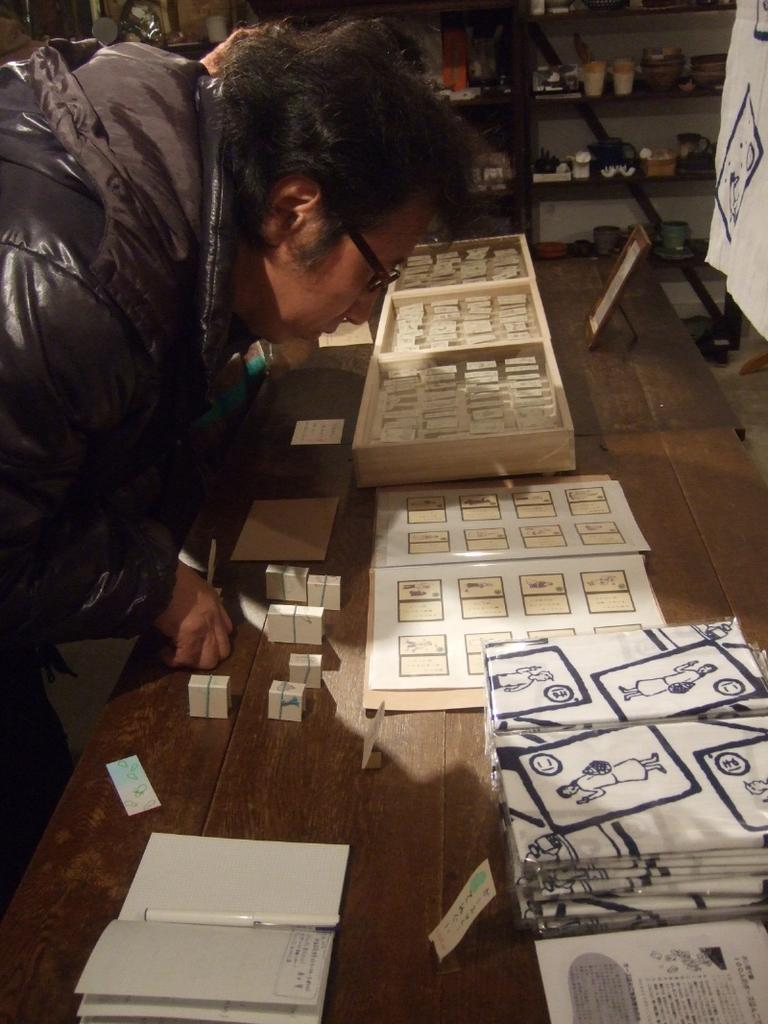Who is present in the image? There is a man in the image. What is in front of the man? There are tables in front of the man. What can be found on the tables? There are objects on the tables. What can be seen in the background of the image? There are racks in the background of the image. What is on the racks? There are objects on the racks. Are there any fairies flying around the man in the image? No, there are no fairies present in the image. 